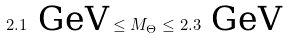Convert formula to latex. <formula><loc_0><loc_0><loc_500><loc_500>2 . 1 \text { GeV} \leq M _ { \Theta } \leq 2 . 3 \text { GeV}</formula> 